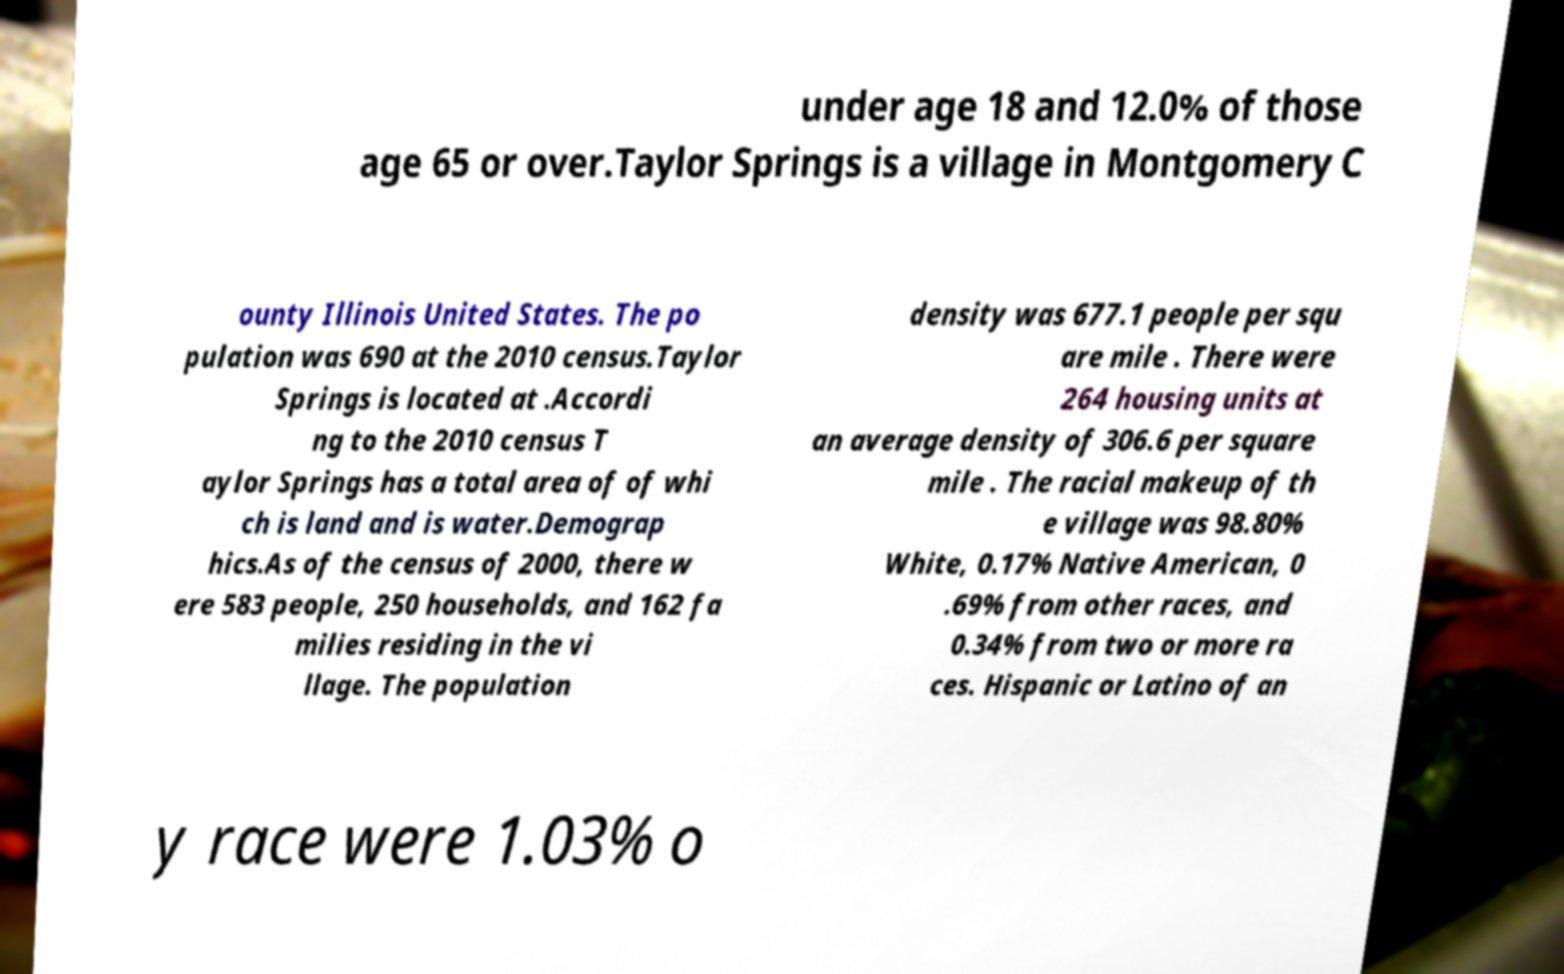Please identify and transcribe the text found in this image. under age 18 and 12.0% of those age 65 or over.Taylor Springs is a village in Montgomery C ounty Illinois United States. The po pulation was 690 at the 2010 census.Taylor Springs is located at .Accordi ng to the 2010 census T aylor Springs has a total area of of whi ch is land and is water.Demograp hics.As of the census of 2000, there w ere 583 people, 250 households, and 162 fa milies residing in the vi llage. The population density was 677.1 people per squ are mile . There were 264 housing units at an average density of 306.6 per square mile . The racial makeup of th e village was 98.80% White, 0.17% Native American, 0 .69% from other races, and 0.34% from two or more ra ces. Hispanic or Latino of an y race were 1.03% o 